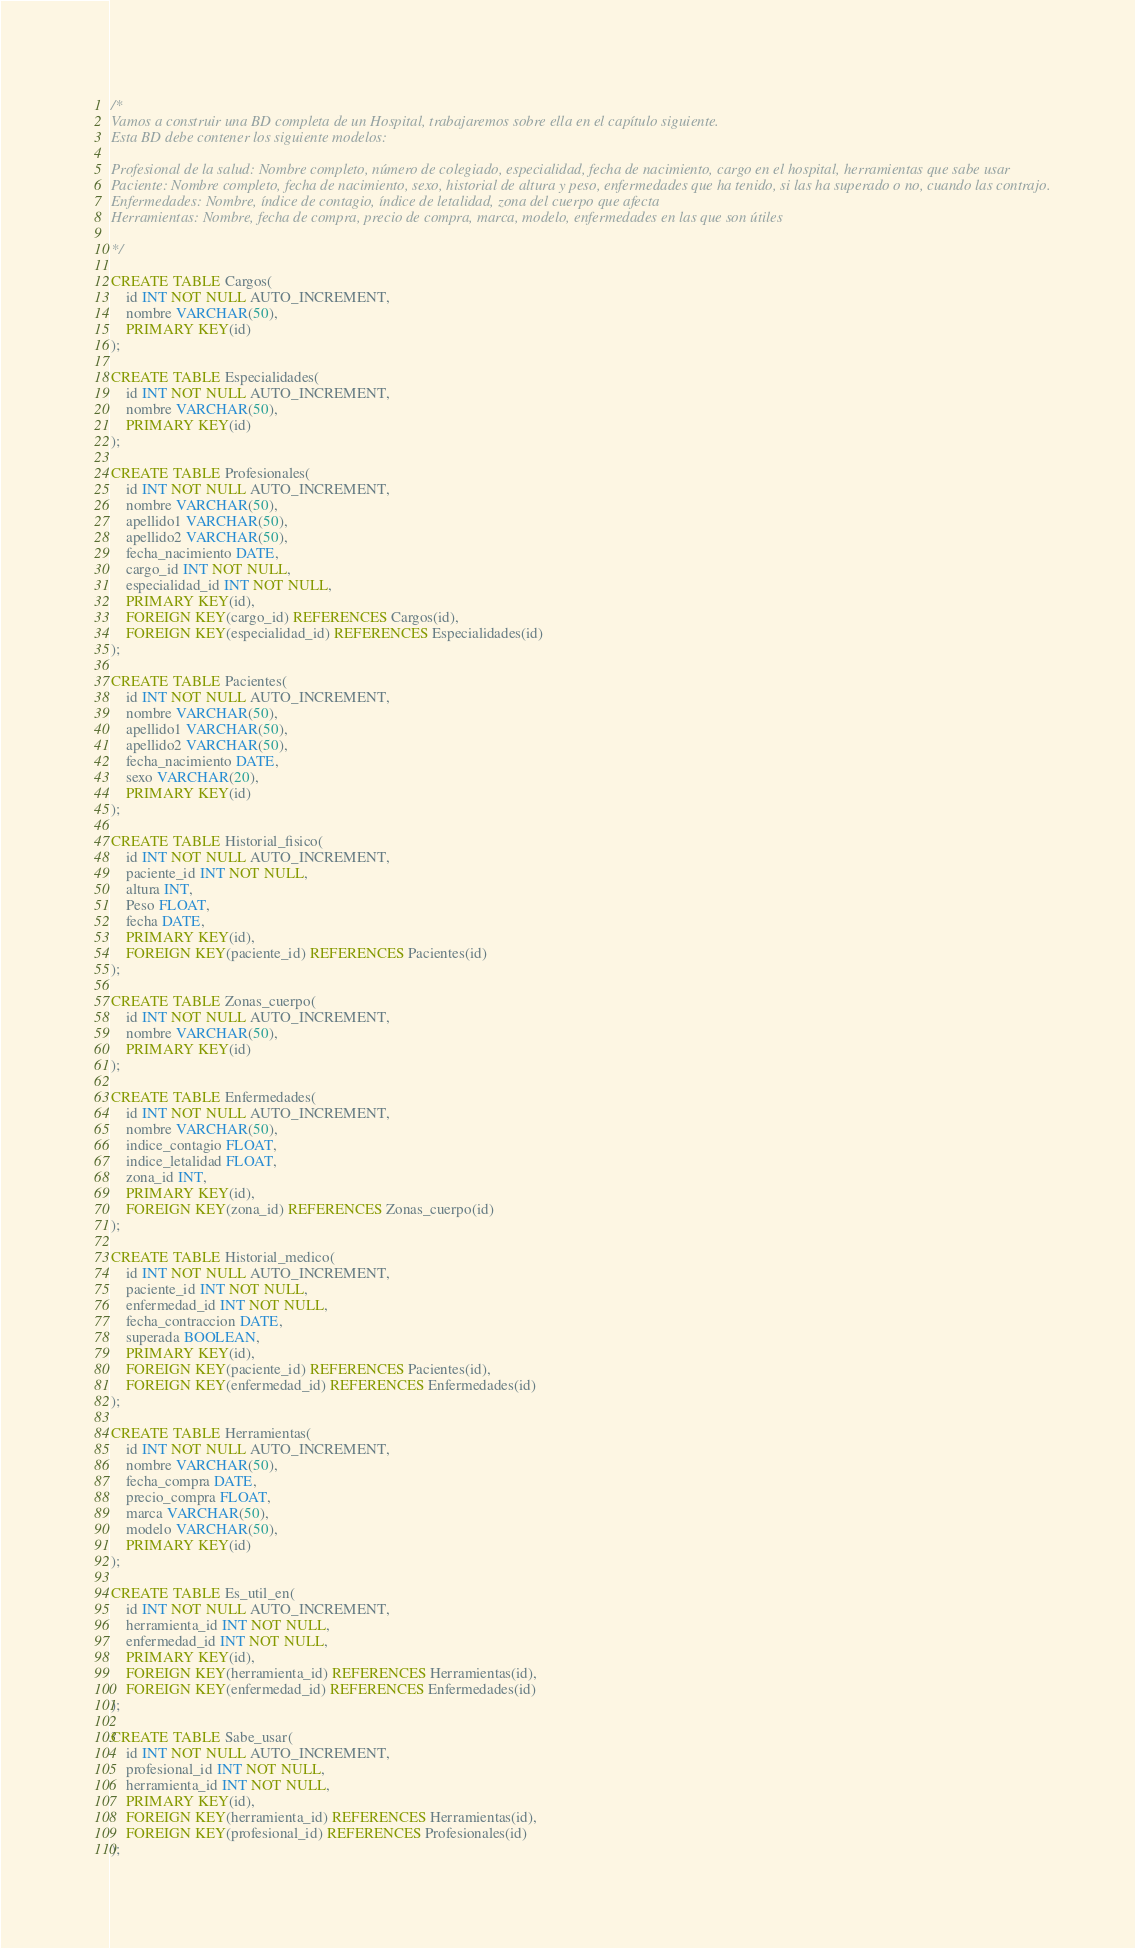<code> <loc_0><loc_0><loc_500><loc_500><_SQL_>/*
Vamos a construir una BD completa de un Hospital, trabajaremos sobre ella en el capítulo siguiente.
Esta BD debe contener los siguiente modelos:

Profesional de la salud: Nombre completo, número de colegiado, especialidad, fecha de nacimiento, cargo en el hospital, herramientas que sabe usar
Paciente: Nombre completo, fecha de nacimiento, sexo, historial de altura y peso, enfermedades que ha tenido, si las ha superado o no, cuando las contrajo.
Enfermedades: Nombre, índice de contagio, índice de letalidad, zona del cuerpo que afecta
Herramientas: Nombre, fecha de compra, precio de compra, marca, modelo, enfermedades en las que son útiles

*/

CREATE TABLE Cargos(
    id INT NOT NULL AUTO_INCREMENT,
    nombre VARCHAR(50),
    PRIMARY KEY(id)
);

CREATE TABLE Especialidades(
    id INT NOT NULL AUTO_INCREMENT,
    nombre VARCHAR(50),
    PRIMARY KEY(id)
);

CREATE TABLE Profesionales(
    id INT NOT NULL AUTO_INCREMENT,
    nombre VARCHAR(50),
    apellido1 VARCHAR(50),
    apellido2 VARCHAR(50),
    fecha_nacimiento DATE,
    cargo_id INT NOT NULL,
    especialidad_id INT NOT NULL,
    PRIMARY KEY(id),
    FOREIGN KEY(cargo_id) REFERENCES Cargos(id),
    FOREIGN KEY(especialidad_id) REFERENCES Especialidades(id)
);

CREATE TABLE Pacientes(
    id INT NOT NULL AUTO_INCREMENT,
    nombre VARCHAR(50),
    apellido1 VARCHAR(50),
    apellido2 VARCHAR(50),
    fecha_nacimiento DATE,
    sexo VARCHAR(20),
    PRIMARY KEY(id)
);

CREATE TABLE Historial_fisico(
    id INT NOT NULL AUTO_INCREMENT,
    paciente_id INT NOT NULL,
    altura INT,
    Peso FLOAT,
    fecha DATE,
    PRIMARY KEY(id),
    FOREIGN KEY(paciente_id) REFERENCES Pacientes(id)
);

CREATE TABLE Zonas_cuerpo(
    id INT NOT NULL AUTO_INCREMENT,
    nombre VARCHAR(50),
    PRIMARY KEY(id)
);

CREATE TABLE Enfermedades(
    id INT NOT NULL AUTO_INCREMENT,
    nombre VARCHAR(50),
    indice_contagio FLOAT,
    indice_letalidad FLOAT,
    zona_id INT,
    PRIMARY KEY(id),
    FOREIGN KEY(zona_id) REFERENCES Zonas_cuerpo(id)
);

CREATE TABLE Historial_medico(
    id INT NOT NULL AUTO_INCREMENT,
    paciente_id INT NOT NULL,
    enfermedad_id INT NOT NULL,
    fecha_contraccion DATE,
    superada BOOLEAN,
    PRIMARY KEY(id),
    FOREIGN KEY(paciente_id) REFERENCES Pacientes(id),
    FOREIGN KEY(enfermedad_id) REFERENCES Enfermedades(id)
);

CREATE TABLE Herramientas(
    id INT NOT NULL AUTO_INCREMENT,
    nombre VARCHAR(50),
    fecha_compra DATE,
    precio_compra FLOAT,
    marca VARCHAR(50),
    modelo VARCHAR(50),
    PRIMARY KEY(id)
);

CREATE TABLE Es_util_en(
    id INT NOT NULL AUTO_INCREMENT,
    herramienta_id INT NOT NULL,
    enfermedad_id INT NOT NULL,
    PRIMARY KEY(id),
    FOREIGN KEY(herramienta_id) REFERENCES Herramientas(id),
    FOREIGN KEY(enfermedad_id) REFERENCES Enfermedades(id)
);

CREATE TABLE Sabe_usar(
    id INT NOT NULL AUTO_INCREMENT,
    profesional_id INT NOT NULL,
    herramienta_id INT NOT NULL,
    PRIMARY KEY(id),
    FOREIGN KEY(herramienta_id) REFERENCES Herramientas(id),
    FOREIGN KEY(profesional_id) REFERENCES Profesionales(id)
);</code> 